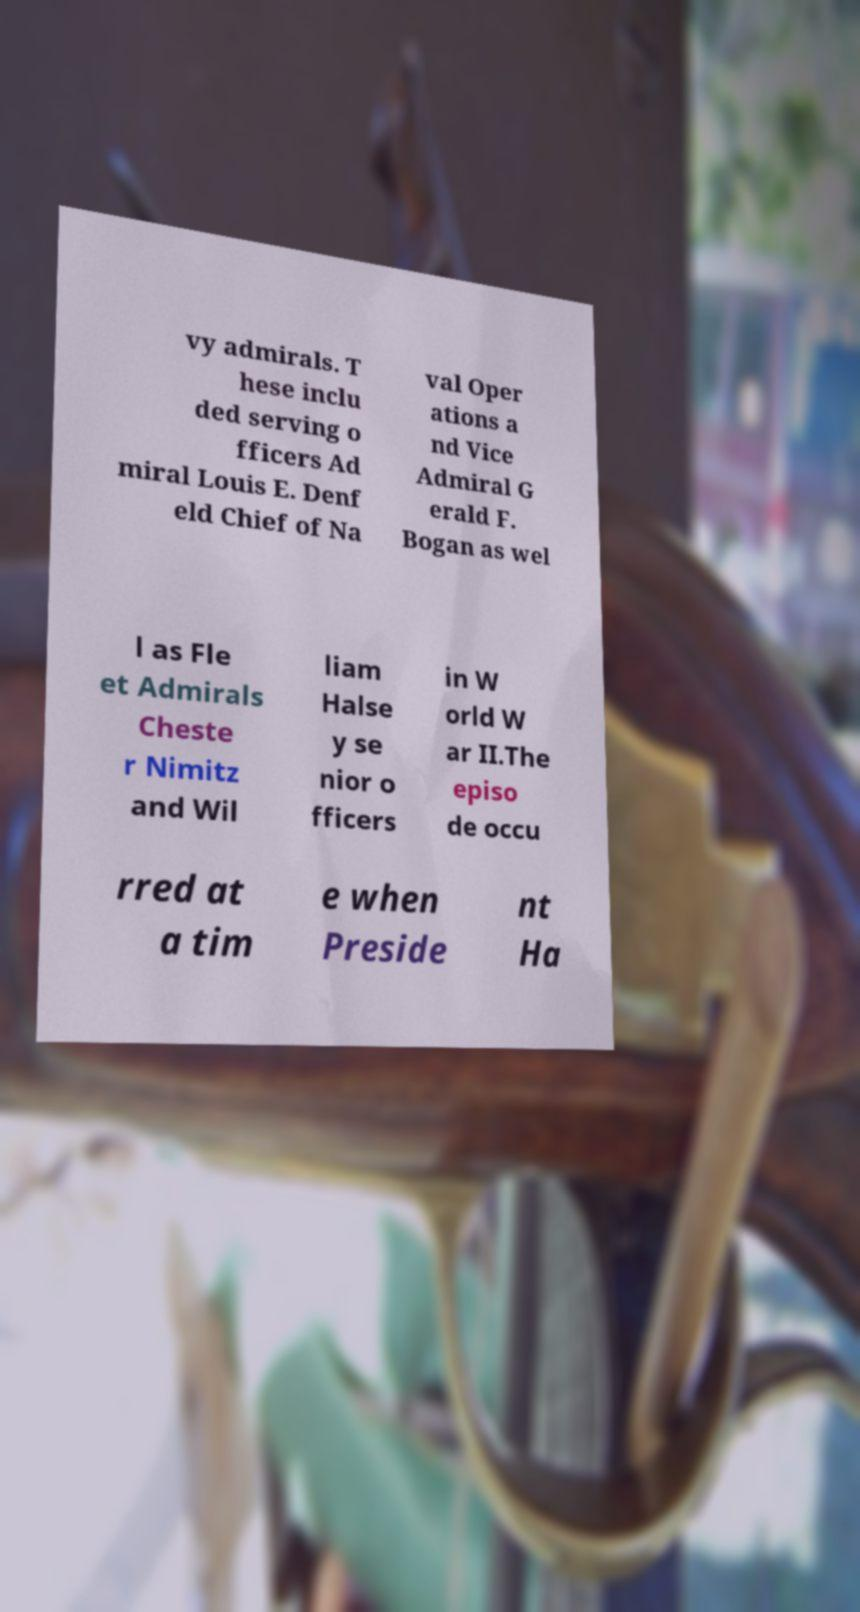Could you assist in decoding the text presented in this image and type it out clearly? vy admirals. T hese inclu ded serving o fficers Ad miral Louis E. Denf eld Chief of Na val Oper ations a nd Vice Admiral G erald F. Bogan as wel l as Fle et Admirals Cheste r Nimitz and Wil liam Halse y se nior o fficers in W orld W ar II.The episo de occu rred at a tim e when Preside nt Ha 